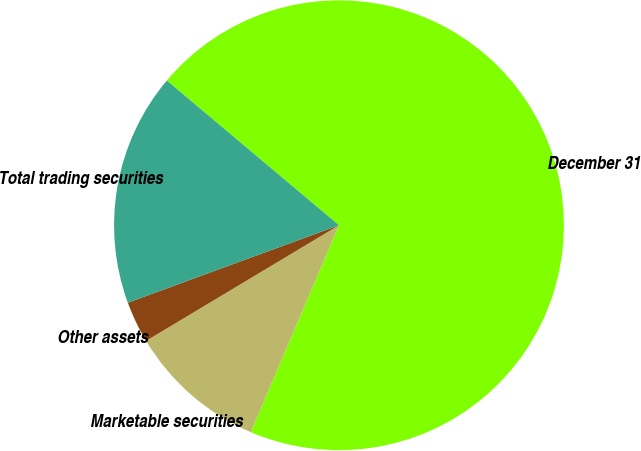Convert chart to OTSL. <chart><loc_0><loc_0><loc_500><loc_500><pie_chart><fcel>December 31<fcel>Marketable securities<fcel>Other assets<fcel>Total trading securities<nl><fcel>70.29%<fcel>9.99%<fcel>3.0%<fcel>16.72%<nl></chart> 